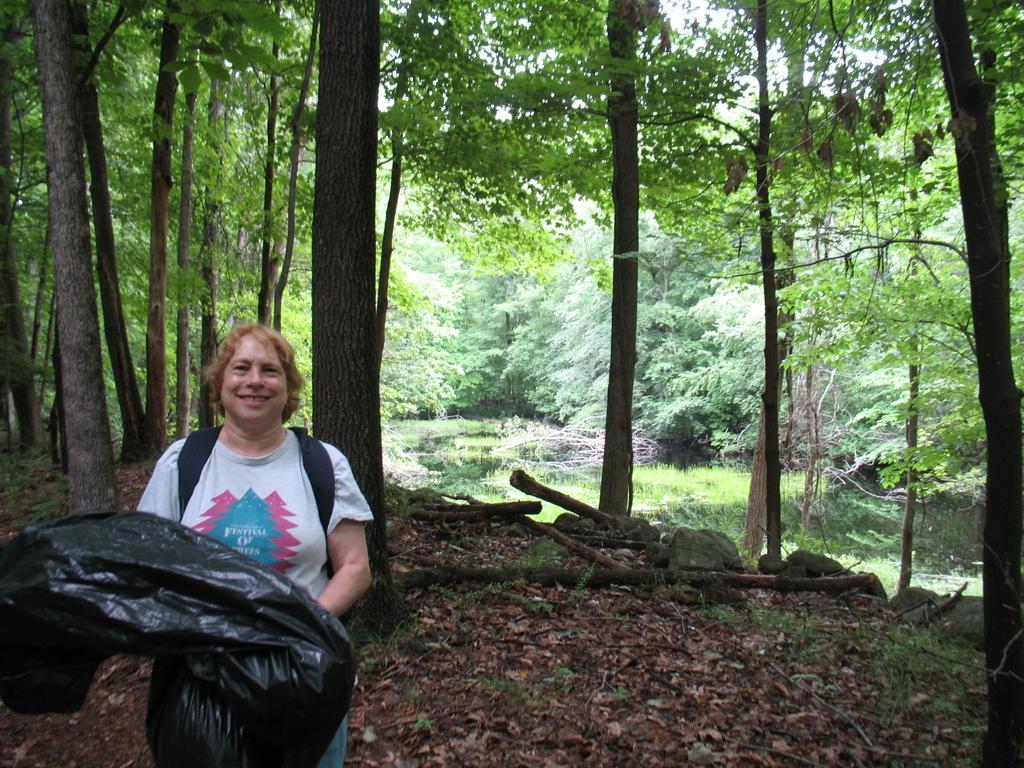Describe this image in one or two sentences. In this image we can see a person standing and smiling and holding a black color cover. In the background we can see many trees and at the bottom there are dried leaves. Water is also visible in this image. 